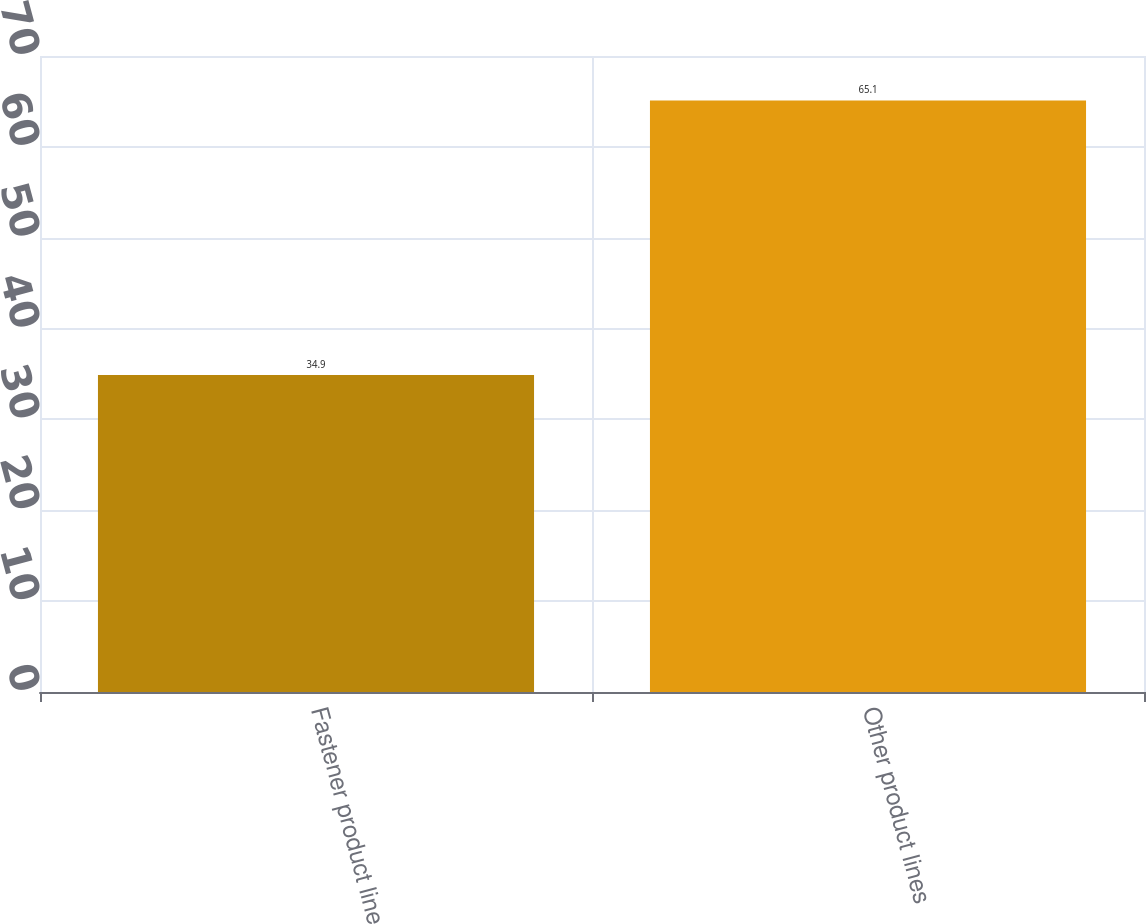Convert chart to OTSL. <chart><loc_0><loc_0><loc_500><loc_500><bar_chart><fcel>Fastener product line<fcel>Other product lines<nl><fcel>34.9<fcel>65.1<nl></chart> 